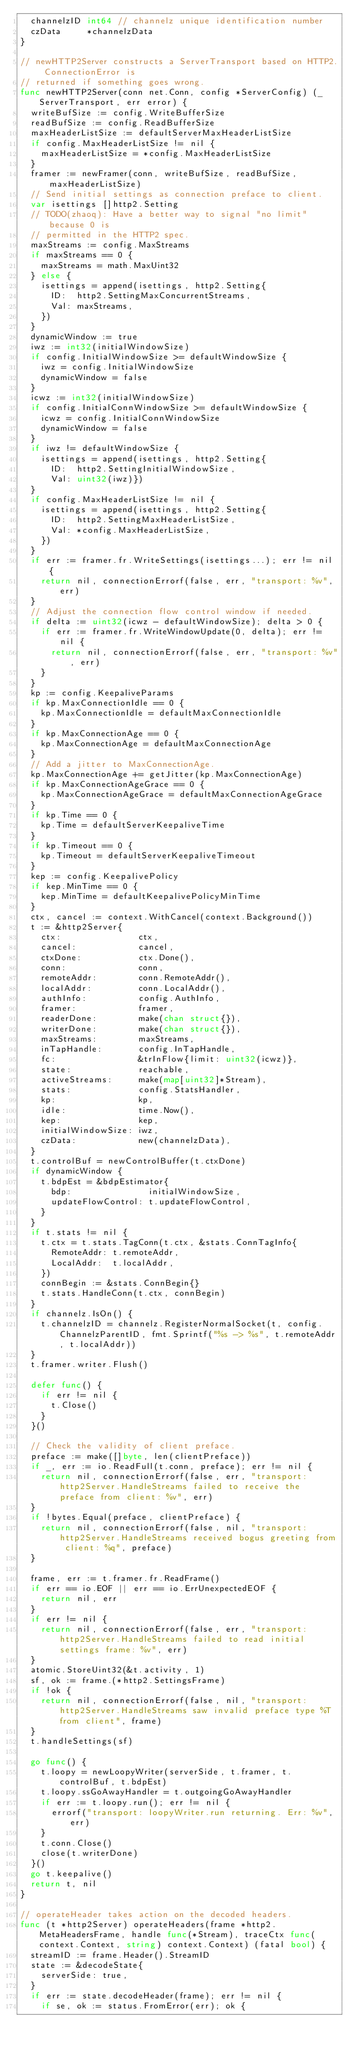<code> <loc_0><loc_0><loc_500><loc_500><_Go_>	channelzID int64 // channelz unique identification number
	czData     *channelzData
}

// newHTTP2Server constructs a ServerTransport based on HTTP2. ConnectionError is
// returned if something goes wrong.
func newHTTP2Server(conn net.Conn, config *ServerConfig) (_ ServerTransport, err error) {
	writeBufSize := config.WriteBufferSize
	readBufSize := config.ReadBufferSize
	maxHeaderListSize := defaultServerMaxHeaderListSize
	if config.MaxHeaderListSize != nil {
		maxHeaderListSize = *config.MaxHeaderListSize
	}
	framer := newFramer(conn, writeBufSize, readBufSize, maxHeaderListSize)
	// Send initial settings as connection preface to client.
	var isettings []http2.Setting
	// TODO(zhaoq): Have a better way to signal "no limit" because 0 is
	// permitted in the HTTP2 spec.
	maxStreams := config.MaxStreams
	if maxStreams == 0 {
		maxStreams = math.MaxUint32
	} else {
		isettings = append(isettings, http2.Setting{
			ID:  http2.SettingMaxConcurrentStreams,
			Val: maxStreams,
		})
	}
	dynamicWindow := true
	iwz := int32(initialWindowSize)
	if config.InitialWindowSize >= defaultWindowSize {
		iwz = config.InitialWindowSize
		dynamicWindow = false
	}
	icwz := int32(initialWindowSize)
	if config.InitialConnWindowSize >= defaultWindowSize {
		icwz = config.InitialConnWindowSize
		dynamicWindow = false
	}
	if iwz != defaultWindowSize {
		isettings = append(isettings, http2.Setting{
			ID:  http2.SettingInitialWindowSize,
			Val: uint32(iwz)})
	}
	if config.MaxHeaderListSize != nil {
		isettings = append(isettings, http2.Setting{
			ID:  http2.SettingMaxHeaderListSize,
			Val: *config.MaxHeaderListSize,
		})
	}
	if err := framer.fr.WriteSettings(isettings...); err != nil {
		return nil, connectionErrorf(false, err, "transport: %v", err)
	}
	// Adjust the connection flow control window if needed.
	if delta := uint32(icwz - defaultWindowSize); delta > 0 {
		if err := framer.fr.WriteWindowUpdate(0, delta); err != nil {
			return nil, connectionErrorf(false, err, "transport: %v", err)
		}
	}
	kp := config.KeepaliveParams
	if kp.MaxConnectionIdle == 0 {
		kp.MaxConnectionIdle = defaultMaxConnectionIdle
	}
	if kp.MaxConnectionAge == 0 {
		kp.MaxConnectionAge = defaultMaxConnectionAge
	}
	// Add a jitter to MaxConnectionAge.
	kp.MaxConnectionAge += getJitter(kp.MaxConnectionAge)
	if kp.MaxConnectionAgeGrace == 0 {
		kp.MaxConnectionAgeGrace = defaultMaxConnectionAgeGrace
	}
	if kp.Time == 0 {
		kp.Time = defaultServerKeepaliveTime
	}
	if kp.Timeout == 0 {
		kp.Timeout = defaultServerKeepaliveTimeout
	}
	kep := config.KeepalivePolicy
	if kep.MinTime == 0 {
		kep.MinTime = defaultKeepalivePolicyMinTime
	}
	ctx, cancel := context.WithCancel(context.Background())
	t := &http2Server{
		ctx:               ctx,
		cancel:            cancel,
		ctxDone:           ctx.Done(),
		conn:              conn,
		remoteAddr:        conn.RemoteAddr(),
		localAddr:         conn.LocalAddr(),
		authInfo:          config.AuthInfo,
		framer:            framer,
		readerDone:        make(chan struct{}),
		writerDone:        make(chan struct{}),
		maxStreams:        maxStreams,
		inTapHandle:       config.InTapHandle,
		fc:                &trInFlow{limit: uint32(icwz)},
		state:             reachable,
		activeStreams:     make(map[uint32]*Stream),
		stats:             config.StatsHandler,
		kp:                kp,
		idle:              time.Now(),
		kep:               kep,
		initialWindowSize: iwz,
		czData:            new(channelzData),
	}
	t.controlBuf = newControlBuffer(t.ctxDone)
	if dynamicWindow {
		t.bdpEst = &bdpEstimator{
			bdp:               initialWindowSize,
			updateFlowControl: t.updateFlowControl,
		}
	}
	if t.stats != nil {
		t.ctx = t.stats.TagConn(t.ctx, &stats.ConnTagInfo{
			RemoteAddr: t.remoteAddr,
			LocalAddr:  t.localAddr,
		})
		connBegin := &stats.ConnBegin{}
		t.stats.HandleConn(t.ctx, connBegin)
	}
	if channelz.IsOn() {
		t.channelzID = channelz.RegisterNormalSocket(t, config.ChannelzParentID, fmt.Sprintf("%s -> %s", t.remoteAddr, t.localAddr))
	}
	t.framer.writer.Flush()

	defer func() {
		if err != nil {
			t.Close()
		}
	}()

	// Check the validity of client preface.
	preface := make([]byte, len(clientPreface))
	if _, err := io.ReadFull(t.conn, preface); err != nil {
		return nil, connectionErrorf(false, err, "transport: http2Server.HandleStreams failed to receive the preface from client: %v", err)
	}
	if !bytes.Equal(preface, clientPreface) {
		return nil, connectionErrorf(false, nil, "transport: http2Server.HandleStreams received bogus greeting from client: %q", preface)
	}

	frame, err := t.framer.fr.ReadFrame()
	if err == io.EOF || err == io.ErrUnexpectedEOF {
		return nil, err
	}
	if err != nil {
		return nil, connectionErrorf(false, err, "transport: http2Server.HandleStreams failed to read initial settings frame: %v", err)
	}
	atomic.StoreUint32(&t.activity, 1)
	sf, ok := frame.(*http2.SettingsFrame)
	if !ok {
		return nil, connectionErrorf(false, nil, "transport: http2Server.HandleStreams saw invalid preface type %T from client", frame)
	}
	t.handleSettings(sf)

	go func() {
		t.loopy = newLoopyWriter(serverSide, t.framer, t.controlBuf, t.bdpEst)
		t.loopy.ssGoAwayHandler = t.outgoingGoAwayHandler
		if err := t.loopy.run(); err != nil {
			errorf("transport: loopyWriter.run returning. Err: %v", err)
		}
		t.conn.Close()
		close(t.writerDone)
	}()
	go t.keepalive()
	return t, nil
}

// operateHeader takes action on the decoded headers.
func (t *http2Server) operateHeaders(frame *http2.MetaHeadersFrame, handle func(*Stream), traceCtx func(context.Context, string) context.Context) (fatal bool) {
	streamID := frame.Header().StreamID
	state := &decodeState{
		serverSide: true,
	}
	if err := state.decodeHeader(frame); err != nil {
		if se, ok := status.FromError(err); ok {</code> 